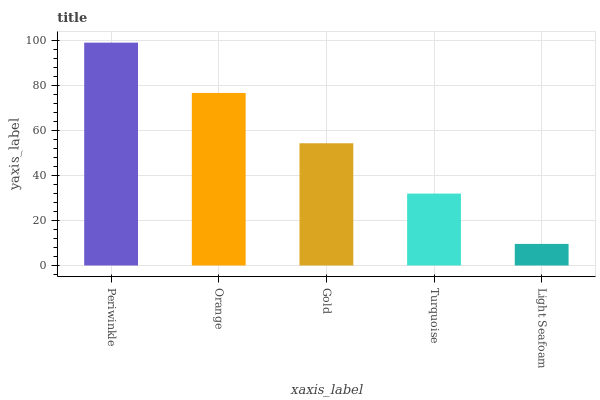Is Light Seafoam the minimum?
Answer yes or no. Yes. Is Periwinkle the maximum?
Answer yes or no. Yes. Is Orange the minimum?
Answer yes or no. No. Is Orange the maximum?
Answer yes or no. No. Is Periwinkle greater than Orange?
Answer yes or no. Yes. Is Orange less than Periwinkle?
Answer yes or no. Yes. Is Orange greater than Periwinkle?
Answer yes or no. No. Is Periwinkle less than Orange?
Answer yes or no. No. Is Gold the high median?
Answer yes or no. Yes. Is Gold the low median?
Answer yes or no. Yes. Is Turquoise the high median?
Answer yes or no. No. Is Turquoise the low median?
Answer yes or no. No. 